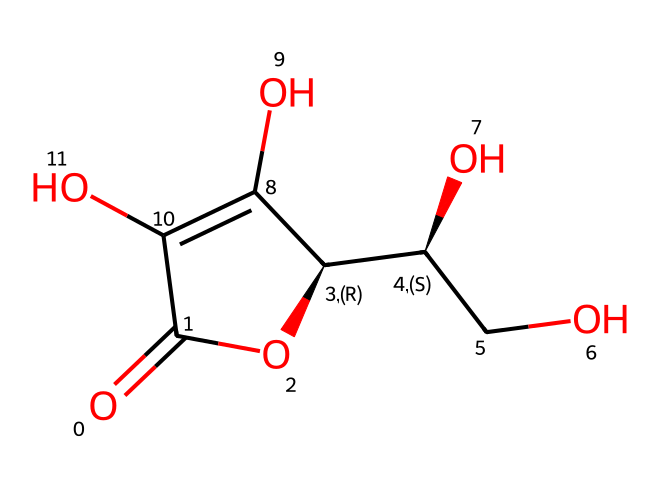What is the molecular formula of ascorbic acid? To determine the molecular formula, count the number of each type of atom in the SMILES representation. Ascorbic acid contains 6 carbon atoms, 8 hydrogen atoms, and 6 oxygen atoms. Thus, the molecular formula is C6H8O6.
Answer: C6H8O6 How many stereocenters are present in ascorbic acid? By analyzing the structure, we can identify stereocenters, which are carbon atoms bonded to four different groups. In ascorbic acid, there are two such carbon atoms providing chirality, indicating two stereocenters.
Answer: 2 What functional groups are present in ascorbic acid? Functional groups are specific groups of atoms responsible for characteristic reactions of the compound. In this case, ascorbic acid contains hydroxyl (–OH) groups and a carbonyl (C=O) group, indicating multiple alcohols and a ketone structure.
Answer: hydroxyl and carbonyl What type of chemical is ascorbic acid categorized as? Ascorbic acid, commonly known as vitamin C, is categorized as an antioxidant due to its ability to inhibit oxidation processes and preserve freshness in foods.
Answer: antioxidant What role does ascorbic acid play in food preservation? Ascorbic acid acts as an antioxidant, which helps prevent browning in fruits and vegetables by inhibiting oxidative reactions that lead to spoilage and loss of freshness.
Answer: prevents browning What are the possible outcomes of ascorbic acid degradation? When ascorbic acid degrades, it can lead to the formation of dehydroascorbic acid, which can further break down into various products, potentially losing its antioxidant properties.
Answer: dehydroascorbic acid How does the presence of hydroxyl groups affect the solubility of ascorbic acid? Hydroxyl groups enhance solubility in water due to their ability to form hydrogen bonds with water molecules. This property allows ascorbic acid to be easily dissolved in aqueous solutions.
Answer: increases solubility 